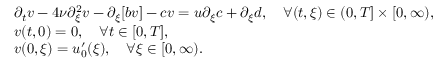<formula> <loc_0><loc_0><loc_500><loc_500>\begin{array} { r l } & { \partial _ { t } v - 4 \nu \partial _ { \xi } ^ { 2 } v - \partial _ { \xi } [ b v ] - c v = u \partial _ { \xi } c + \partial _ { \xi } d , \quad \forall ( t , \xi ) \in ( 0 , T ] \times [ 0 , \infty ) , } \\ & { v ( t , 0 ) = 0 , \quad \forall t \in [ 0 , T ] , } \\ & { v ( 0 , \xi ) = u _ { 0 } ^ { \prime } ( \xi ) , \quad \forall \xi \in [ 0 , \infty ) . } \end{array}</formula> 